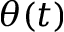<formula> <loc_0><loc_0><loc_500><loc_500>\theta ( t )</formula> 